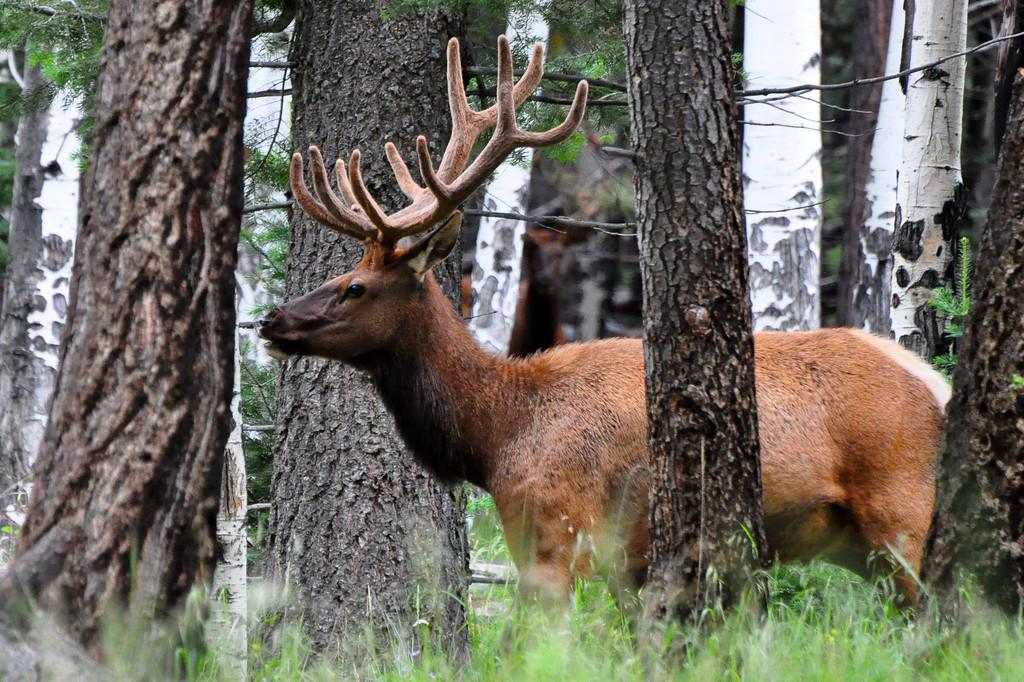What type of animal is in the foreground of the image? The specific type of animal cannot be determined from the provided facts. What can be seen in the background of the image? There are trees in the background of the image. What type of vegetation is visible at the bottom of the image? There is grass visible at the bottom of the image. How does the animal in the image contribute to the addition of new features in the background? The animal in the image does not contribute to any additions, as the image is a static representation. 